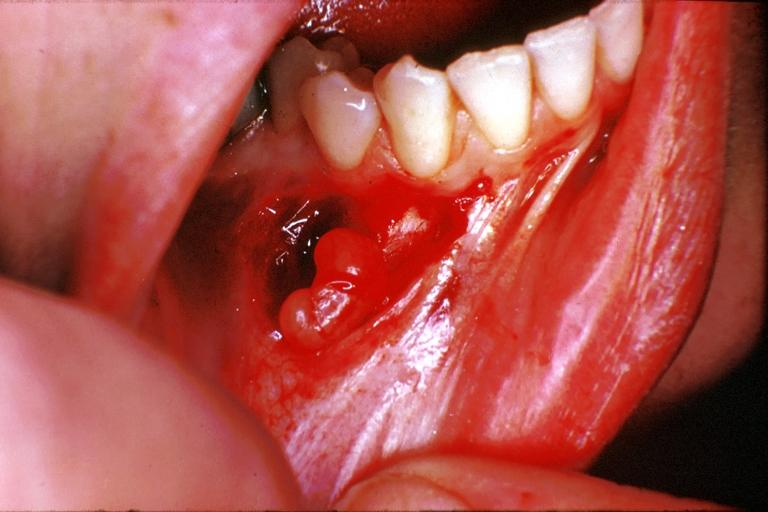does this image show traumatic neuroma?
Answer the question using a single word or phrase. Yes 